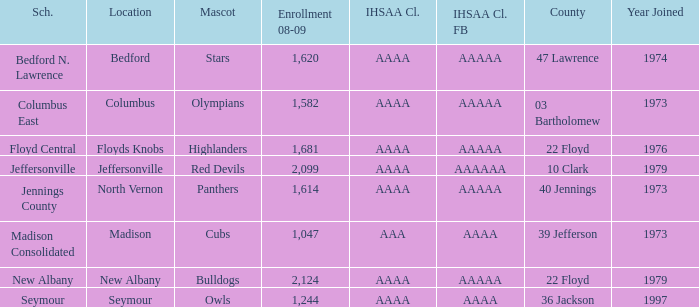What's the IHSAA Class when the school is Seymour? AAAA. 